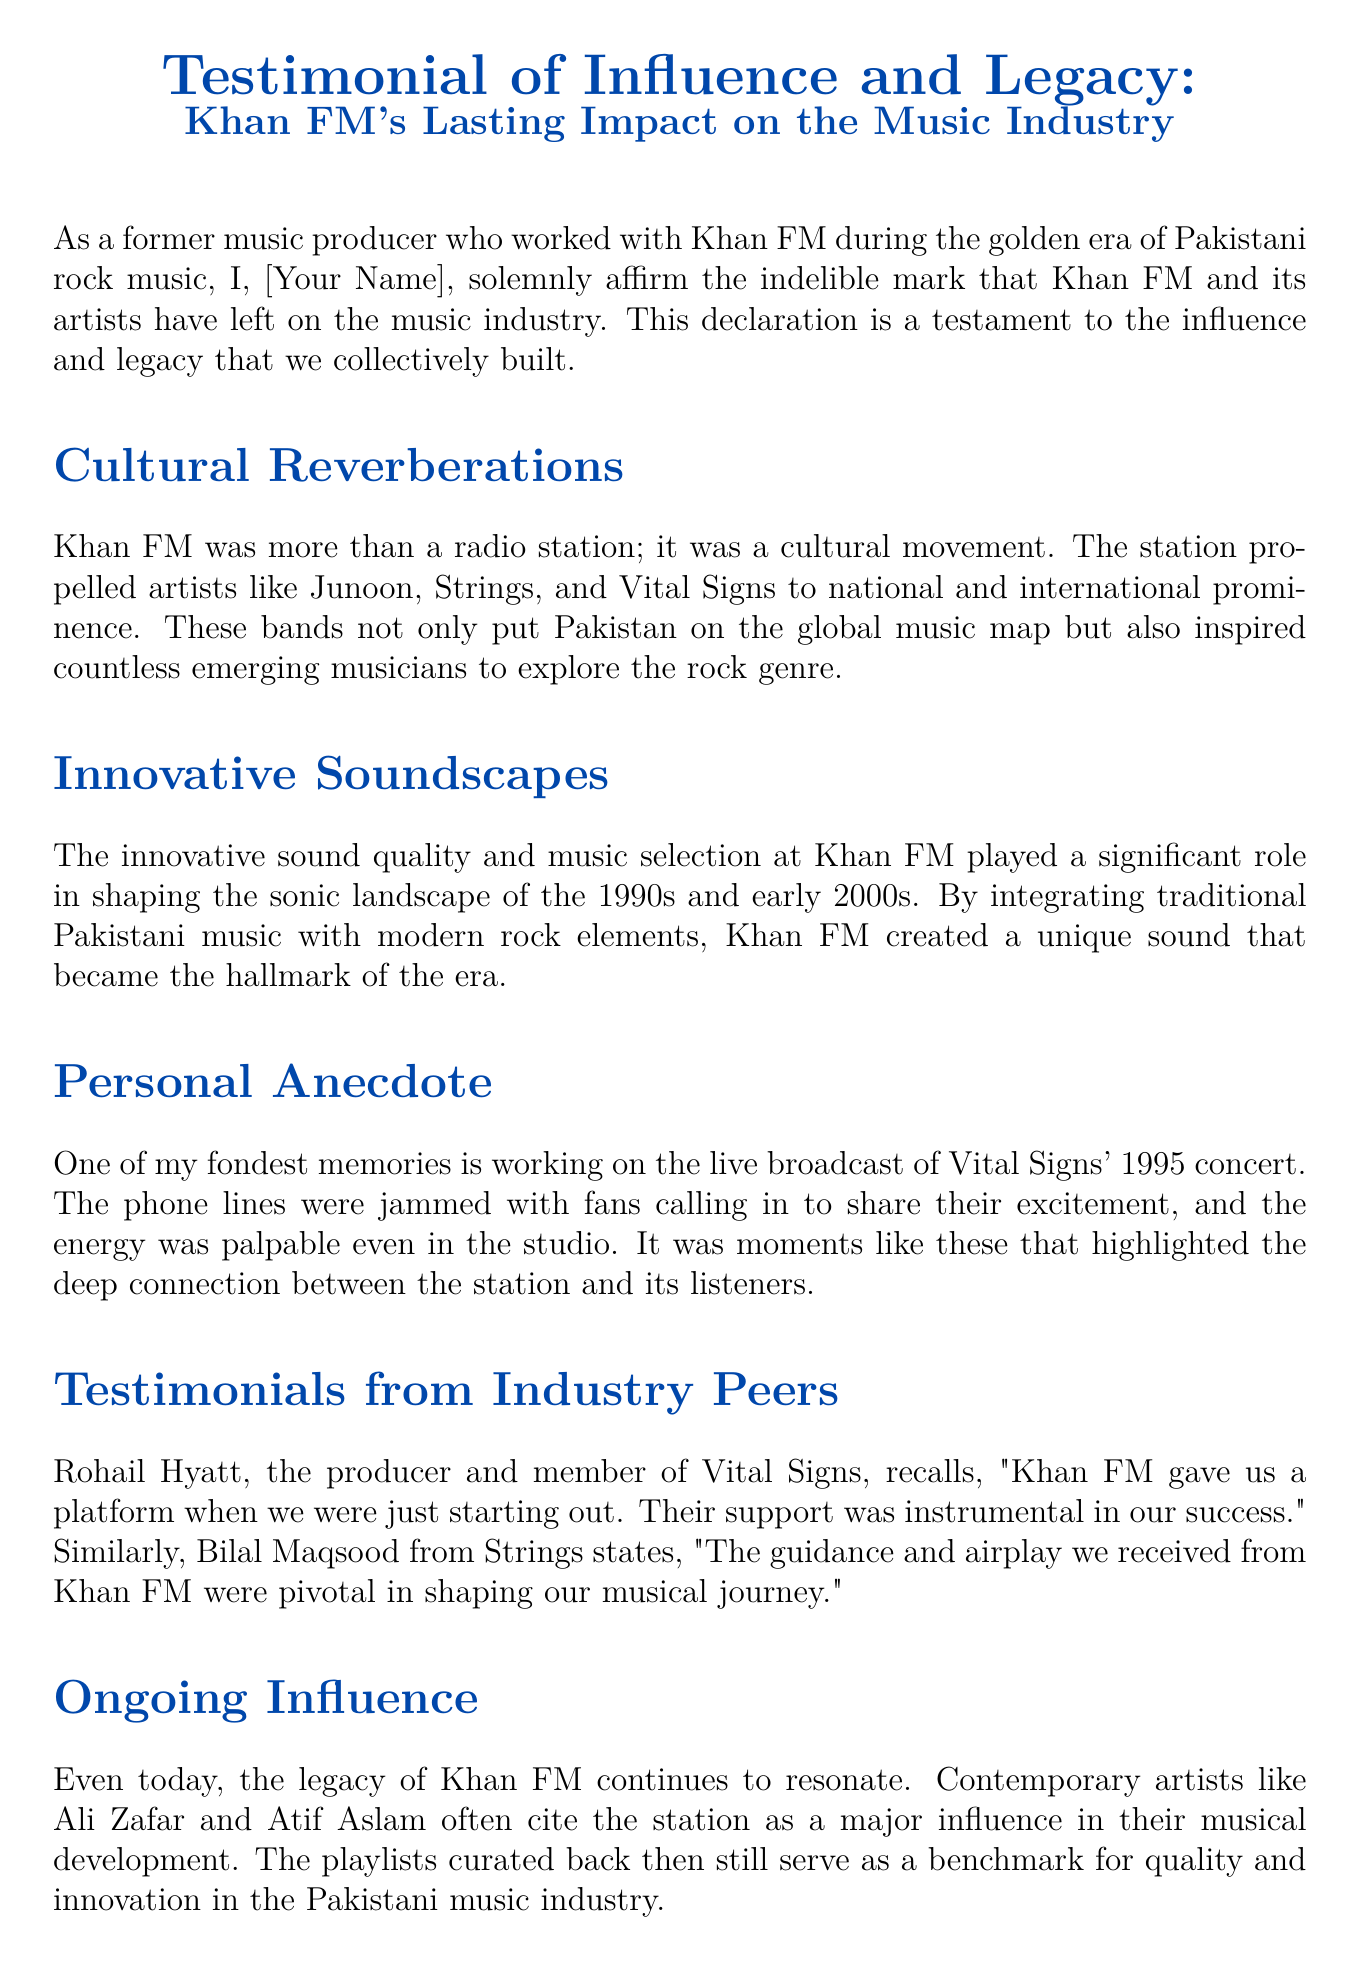What is the title of the declaration? The title of the declaration is stated at the beginning of the document.
Answer: Testimonial of Influence and Legacy: Khan FM's Lasting Impact on the Music Industry Who is the author of the declaration? The author identifies themselves as a former music producer who worked with Khan FM.
Answer: [Your Name] In what year did the live broadcast of Vital Signs' concert occur? The year of the concert is mentioned in the personal anecdote section.
Answer: 1995 Which band is mentioned as a member of Vital Signs? The document includes a quote from a member of this band.
Answer: Rohail Hyatt What genre of music did Khan FM help popularize? The document discusses the type of music associated with Khan FM and its artists.
Answer: Rock Who from Strings commented on their experience with Khan FM? The document features a testimonial from an artist associated with Strings.
Answer: Bilal Maqsood What is described as a hallmark of the sonic landscape created by Khan FM? This detail relates to how Khan FM integrated different musical styles.
Answer: Innovative sound quality Which contemporary artists cite Khan FM as an influence? The document lists artists who reference their impact.
Answer: Ali Zafar and Atif Aslam 